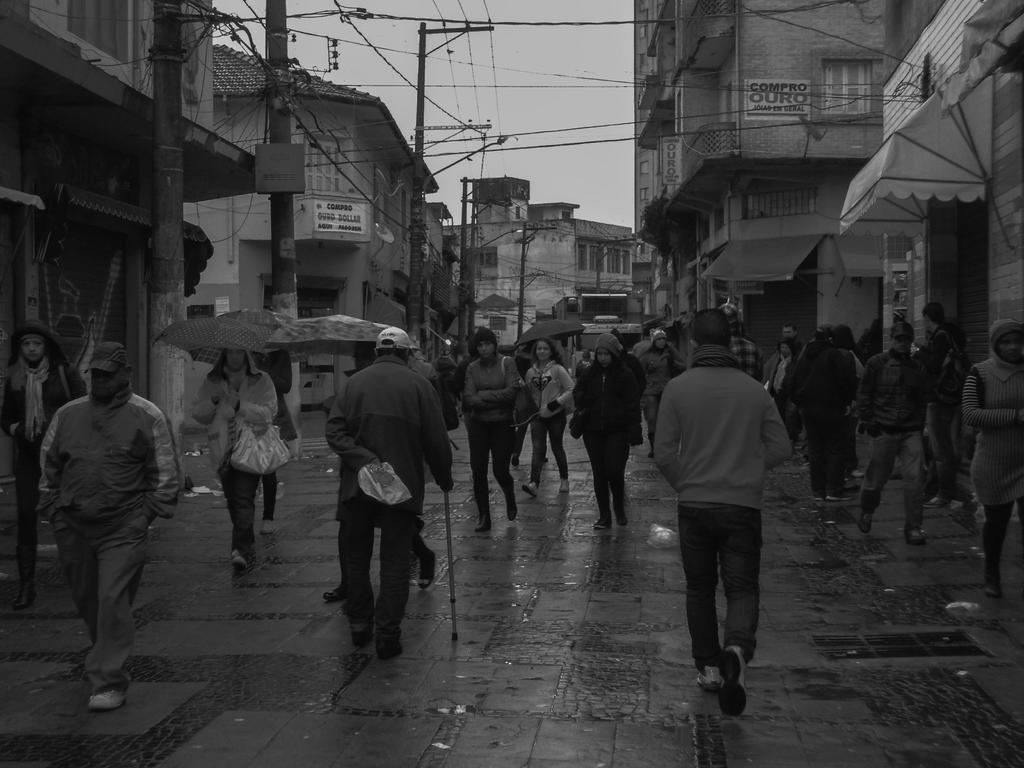In one or two sentences, can you explain what this image depicts? This is a black and white image. In the center of the image we can see some persons are walking and some of them are holding umbrellas, stand and bag. In the background of the image we can see buildings, poles, wires, boards, tent. At the top of the image we can see the sky. At the bottom of the image we can see the road. 